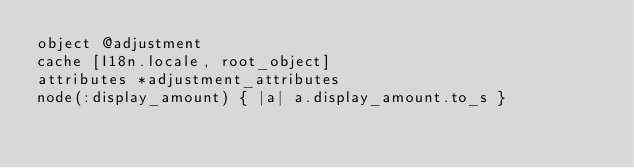<code> <loc_0><loc_0><loc_500><loc_500><_Ruby_>object @adjustment
cache [I18n.locale, root_object]
attributes *adjustment_attributes
node(:display_amount) { |a| a.display_amount.to_s }
</code> 